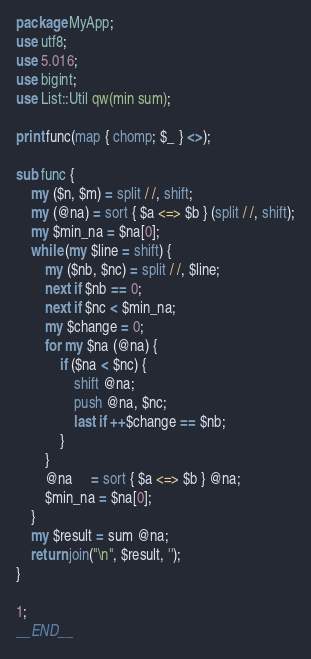<code> <loc_0><loc_0><loc_500><loc_500><_Perl_>package MyApp;
use utf8;
use 5.016;
use bigint;
use List::Util qw(min sum);

print func(map { chomp; $_ } <>);

sub func {
    my ($n, $m) = split / /, shift;
    my (@na) = sort { $a <=> $b } (split / /, shift);
    my $min_na = $na[0];
    while (my $line = shift) {
        my ($nb, $nc) = split / /, $line;
        next if $nb == 0;
        next if $nc < $min_na;
        my $change = 0;
        for my $na (@na) {
            if ($na < $nc) {
                shift @na;
                push @na, $nc;
                last if ++$change == $nb;
            }
        }
        @na     = sort { $a <=> $b } @na;
        $min_na = $na[0];
    }
    my $result = sum @na;
    return join("\n", $result, '');
}

1;
__END__
</code> 